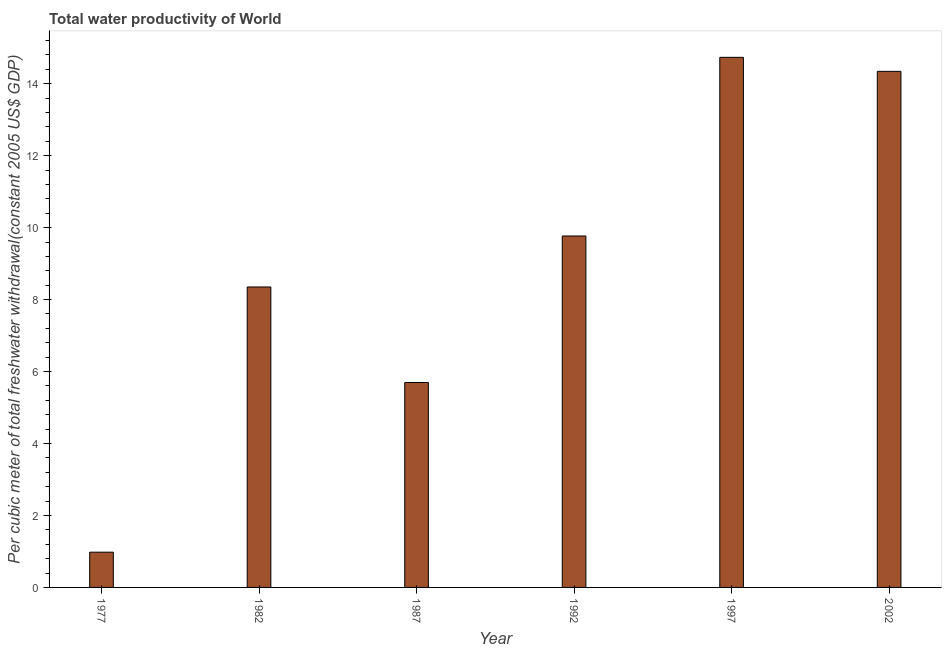Does the graph contain any zero values?
Ensure brevity in your answer.  No. What is the title of the graph?
Give a very brief answer. Total water productivity of World. What is the label or title of the Y-axis?
Provide a succinct answer. Per cubic meter of total freshwater withdrawal(constant 2005 US$ GDP). What is the total water productivity in 1982?
Offer a very short reply. 8.35. Across all years, what is the maximum total water productivity?
Offer a terse response. 14.73. Across all years, what is the minimum total water productivity?
Make the answer very short. 0.98. In which year was the total water productivity maximum?
Your answer should be very brief. 1997. What is the sum of the total water productivity?
Offer a terse response. 53.87. What is the difference between the total water productivity in 1982 and 1987?
Make the answer very short. 2.65. What is the average total water productivity per year?
Keep it short and to the point. 8.98. What is the median total water productivity?
Make the answer very short. 9.06. In how many years, is the total water productivity greater than 2.4 US$?
Your answer should be compact. 5. What is the ratio of the total water productivity in 1977 to that in 1997?
Give a very brief answer. 0.07. What is the difference between the highest and the second highest total water productivity?
Keep it short and to the point. 0.39. What is the difference between the highest and the lowest total water productivity?
Your answer should be very brief. 13.75. How many bars are there?
Offer a terse response. 6. Are all the bars in the graph horizontal?
Your answer should be very brief. No. How many years are there in the graph?
Ensure brevity in your answer.  6. What is the difference between two consecutive major ticks on the Y-axis?
Ensure brevity in your answer.  2. What is the Per cubic meter of total freshwater withdrawal(constant 2005 US$ GDP) of 1977?
Give a very brief answer. 0.98. What is the Per cubic meter of total freshwater withdrawal(constant 2005 US$ GDP) in 1982?
Make the answer very short. 8.35. What is the Per cubic meter of total freshwater withdrawal(constant 2005 US$ GDP) of 1987?
Offer a very short reply. 5.7. What is the Per cubic meter of total freshwater withdrawal(constant 2005 US$ GDP) in 1992?
Offer a very short reply. 9.77. What is the Per cubic meter of total freshwater withdrawal(constant 2005 US$ GDP) in 1997?
Provide a succinct answer. 14.73. What is the Per cubic meter of total freshwater withdrawal(constant 2005 US$ GDP) in 2002?
Offer a very short reply. 14.34. What is the difference between the Per cubic meter of total freshwater withdrawal(constant 2005 US$ GDP) in 1977 and 1982?
Offer a terse response. -7.37. What is the difference between the Per cubic meter of total freshwater withdrawal(constant 2005 US$ GDP) in 1977 and 1987?
Offer a very short reply. -4.72. What is the difference between the Per cubic meter of total freshwater withdrawal(constant 2005 US$ GDP) in 1977 and 1992?
Your response must be concise. -8.79. What is the difference between the Per cubic meter of total freshwater withdrawal(constant 2005 US$ GDP) in 1977 and 1997?
Give a very brief answer. -13.75. What is the difference between the Per cubic meter of total freshwater withdrawal(constant 2005 US$ GDP) in 1977 and 2002?
Provide a short and direct response. -13.36. What is the difference between the Per cubic meter of total freshwater withdrawal(constant 2005 US$ GDP) in 1982 and 1987?
Ensure brevity in your answer.  2.65. What is the difference between the Per cubic meter of total freshwater withdrawal(constant 2005 US$ GDP) in 1982 and 1992?
Your response must be concise. -1.42. What is the difference between the Per cubic meter of total freshwater withdrawal(constant 2005 US$ GDP) in 1982 and 1997?
Make the answer very short. -6.38. What is the difference between the Per cubic meter of total freshwater withdrawal(constant 2005 US$ GDP) in 1982 and 2002?
Give a very brief answer. -5.99. What is the difference between the Per cubic meter of total freshwater withdrawal(constant 2005 US$ GDP) in 1987 and 1992?
Keep it short and to the point. -4.07. What is the difference between the Per cubic meter of total freshwater withdrawal(constant 2005 US$ GDP) in 1987 and 1997?
Offer a very short reply. -9.04. What is the difference between the Per cubic meter of total freshwater withdrawal(constant 2005 US$ GDP) in 1987 and 2002?
Provide a succinct answer. -8.65. What is the difference between the Per cubic meter of total freshwater withdrawal(constant 2005 US$ GDP) in 1992 and 1997?
Give a very brief answer. -4.97. What is the difference between the Per cubic meter of total freshwater withdrawal(constant 2005 US$ GDP) in 1992 and 2002?
Provide a short and direct response. -4.58. What is the difference between the Per cubic meter of total freshwater withdrawal(constant 2005 US$ GDP) in 1997 and 2002?
Give a very brief answer. 0.39. What is the ratio of the Per cubic meter of total freshwater withdrawal(constant 2005 US$ GDP) in 1977 to that in 1982?
Your answer should be compact. 0.12. What is the ratio of the Per cubic meter of total freshwater withdrawal(constant 2005 US$ GDP) in 1977 to that in 1987?
Provide a succinct answer. 0.17. What is the ratio of the Per cubic meter of total freshwater withdrawal(constant 2005 US$ GDP) in 1977 to that in 1997?
Offer a terse response. 0.07. What is the ratio of the Per cubic meter of total freshwater withdrawal(constant 2005 US$ GDP) in 1977 to that in 2002?
Provide a succinct answer. 0.07. What is the ratio of the Per cubic meter of total freshwater withdrawal(constant 2005 US$ GDP) in 1982 to that in 1987?
Your response must be concise. 1.47. What is the ratio of the Per cubic meter of total freshwater withdrawal(constant 2005 US$ GDP) in 1982 to that in 1992?
Your answer should be compact. 0.85. What is the ratio of the Per cubic meter of total freshwater withdrawal(constant 2005 US$ GDP) in 1982 to that in 1997?
Provide a short and direct response. 0.57. What is the ratio of the Per cubic meter of total freshwater withdrawal(constant 2005 US$ GDP) in 1982 to that in 2002?
Your response must be concise. 0.58. What is the ratio of the Per cubic meter of total freshwater withdrawal(constant 2005 US$ GDP) in 1987 to that in 1992?
Provide a succinct answer. 0.58. What is the ratio of the Per cubic meter of total freshwater withdrawal(constant 2005 US$ GDP) in 1987 to that in 1997?
Give a very brief answer. 0.39. What is the ratio of the Per cubic meter of total freshwater withdrawal(constant 2005 US$ GDP) in 1987 to that in 2002?
Give a very brief answer. 0.4. What is the ratio of the Per cubic meter of total freshwater withdrawal(constant 2005 US$ GDP) in 1992 to that in 1997?
Offer a very short reply. 0.66. What is the ratio of the Per cubic meter of total freshwater withdrawal(constant 2005 US$ GDP) in 1992 to that in 2002?
Provide a succinct answer. 0.68. 